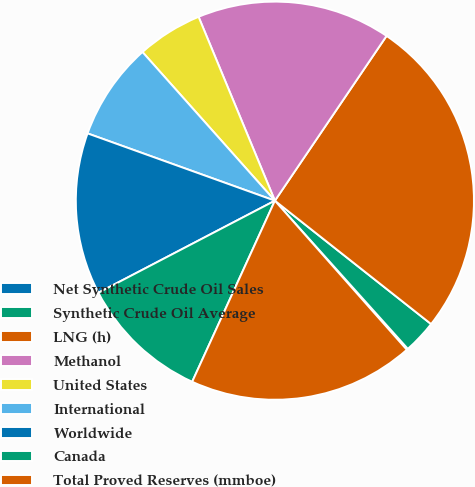Convert chart to OTSL. <chart><loc_0><loc_0><loc_500><loc_500><pie_chart><fcel>Net Synthetic Crude Oil Sales<fcel>Synthetic Crude Oil Average<fcel>LNG (h)<fcel>Methanol<fcel>United States<fcel>International<fcel>Worldwide<fcel>Canada<fcel>Total Proved Reserves (mmboe)<nl><fcel>0.11%<fcel>2.72%<fcel>26.16%<fcel>15.74%<fcel>5.32%<fcel>7.93%<fcel>13.14%<fcel>10.53%<fcel>18.35%<nl></chart> 